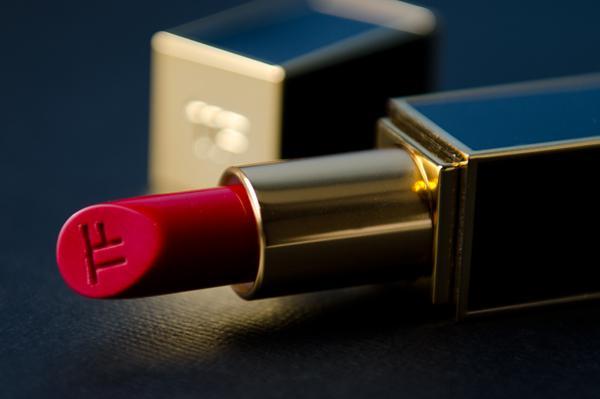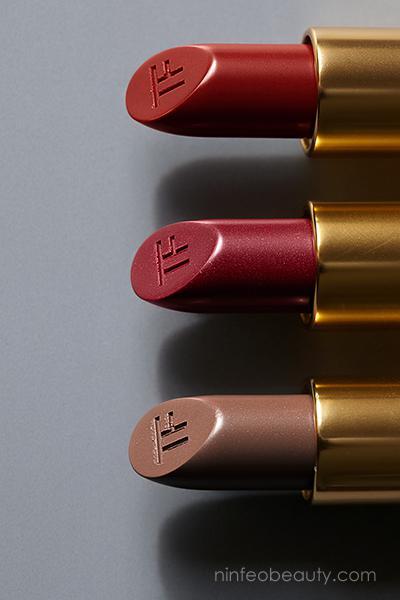The first image is the image on the left, the second image is the image on the right. Assess this claim about the two images: "There are at least 3 tubes of lipstick in these.". Correct or not? Answer yes or no. Yes. The first image is the image on the left, the second image is the image on the right. Analyze the images presented: Is the assertion "There are multiple lines of lip stick color on an arm." valid? Answer yes or no. No. 